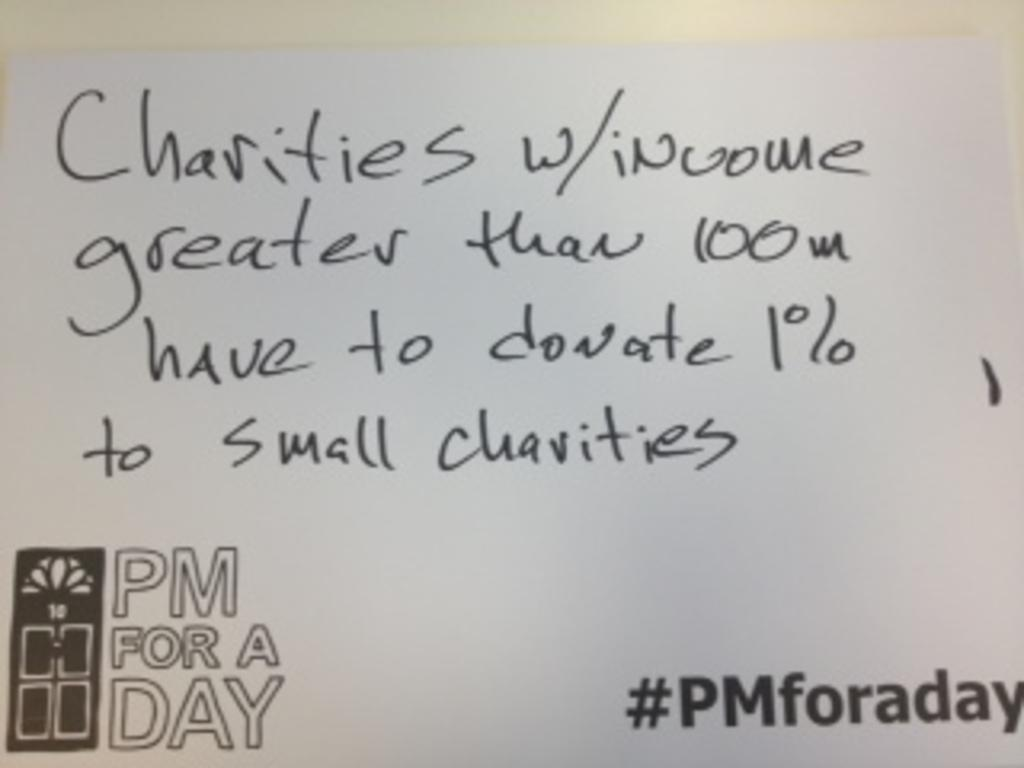Provide a one-sentence caption for the provided image. Some text regarding large and small charities is written on a white board. 